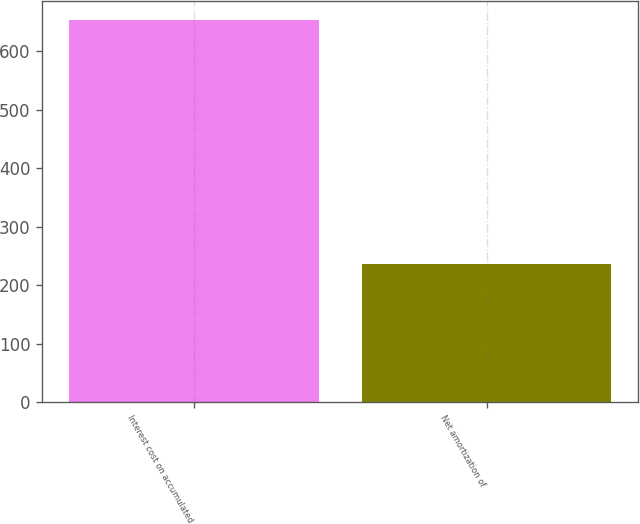<chart> <loc_0><loc_0><loc_500><loc_500><bar_chart><fcel>Interest cost on accumulated<fcel>Net amortization of<nl><fcel>654<fcel>236<nl></chart> 